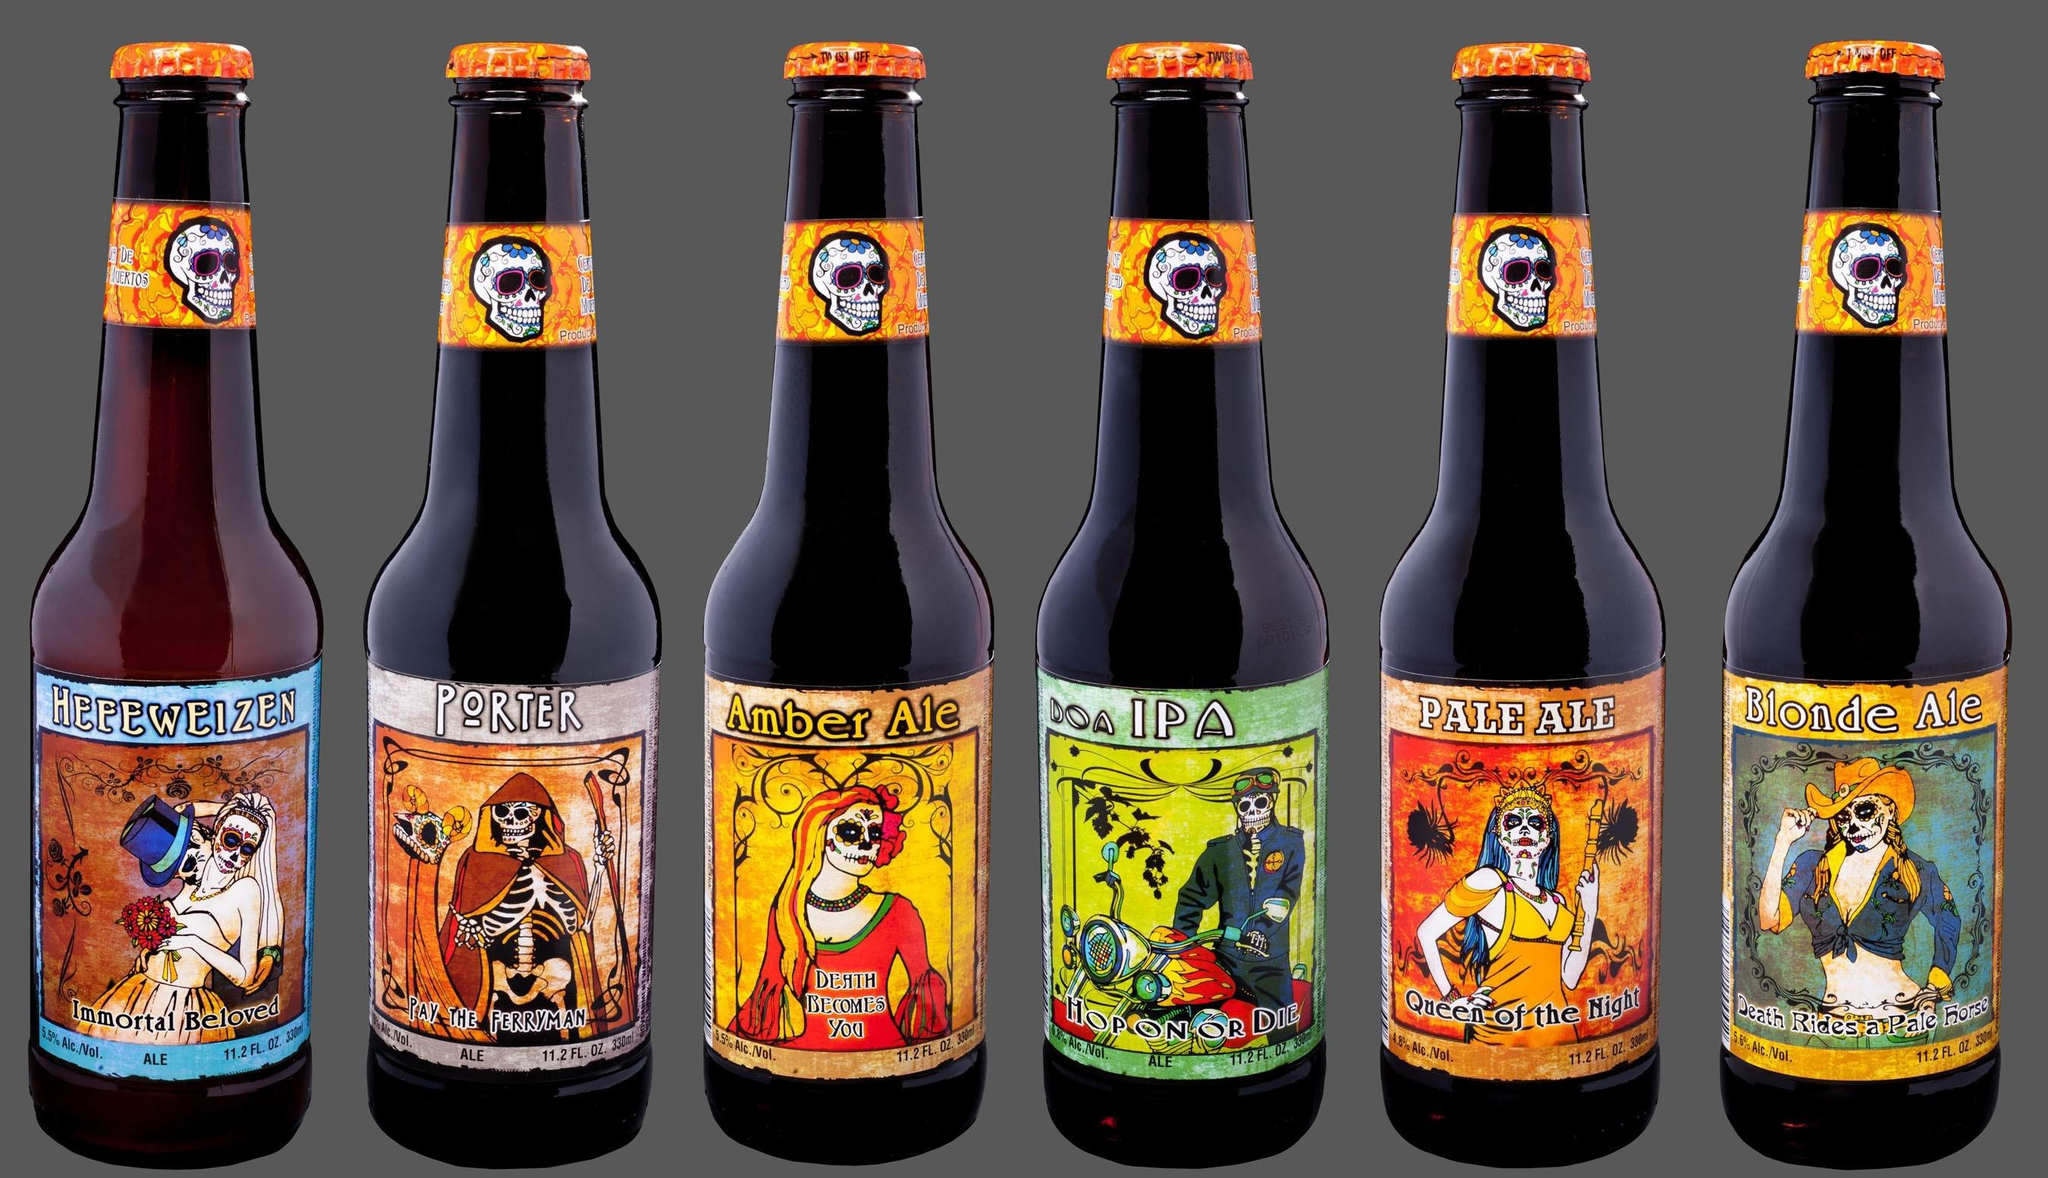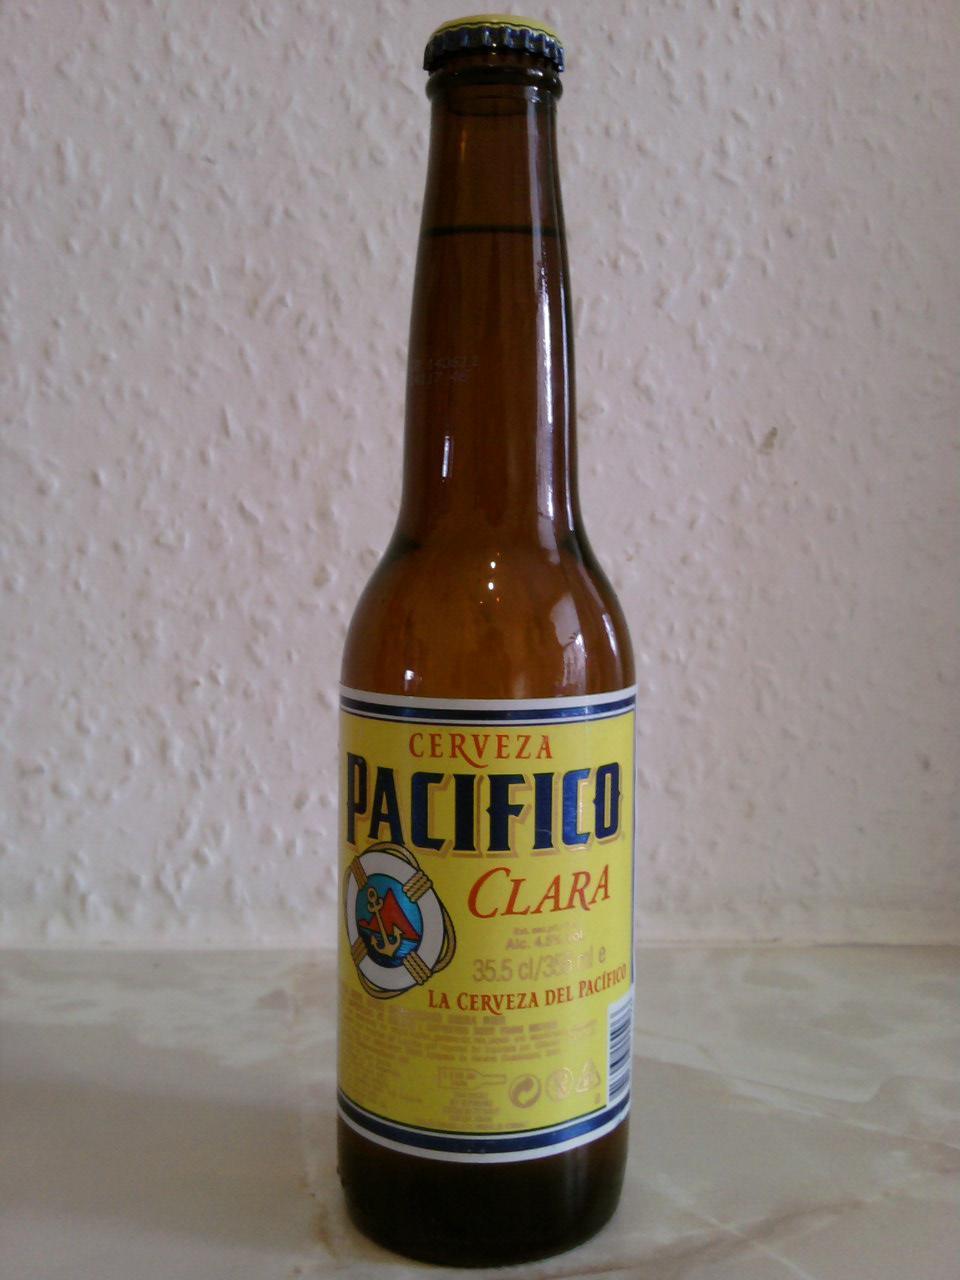The first image is the image on the left, the second image is the image on the right. Analyze the images presented: Is the assertion "One image contains exactly two brown glass beer bottles standing on a table, and no image contains more than three glass bottles." valid? Answer yes or no. No. The first image is the image on the left, the second image is the image on the right. Assess this claim about the two images: "There are exactly two bottles in one of the images.". Correct or not? Answer yes or no. No. 